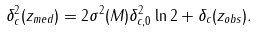Convert formula to latex. <formula><loc_0><loc_0><loc_500><loc_500>\delta _ { c } ^ { 2 } ( z _ { m e d } ) = 2 \sigma ^ { 2 } ( M ) \delta _ { c , 0 } ^ { 2 } \ln 2 + \delta _ { c } ( z _ { o b s } ) .</formula> 